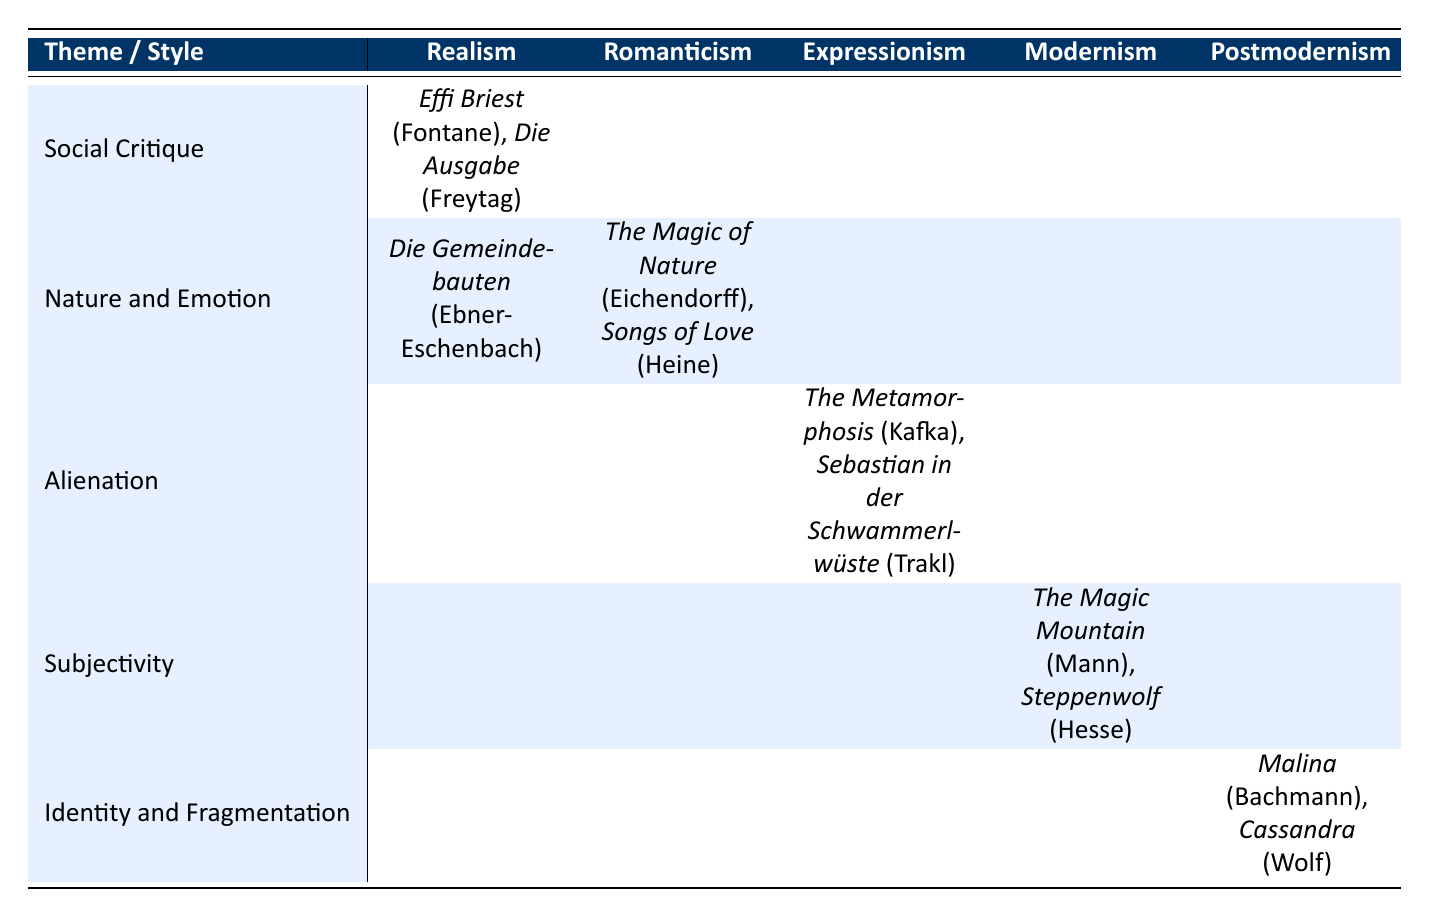What authors are associated with the theme of Social Critique in Realism? The table lists the authors associated with the theme of Social Critique in Realism as Theodor Fontane and Gustav Freytag.
Answer: Theodor Fontane, Gustav Freytag Which works are linked to the theme of Nature and Emotion under Romanticism? The table shows that the works linked to the theme of Nature and Emotion under Romanticism are The Magic of Nature by Joseph von Eichendorff and Songs of Love by Heinrich Heine.
Answer: The Magic of Nature, Songs of Love Is there any work listed under Expressionism that focuses on Alienation? The table indicates that there are works related to Expressionism and the theme of Alienation: The Metamorphosis by Franz Kafka and Sebastian in der Schwammerlwüste by Georg Trakl. This confirms that there are indeed works associated with that theme.
Answer: Yes Count the total number of authors listed in the table. By reviewing the table, the authors are: Theodor Fontane, Gustav Freytag, Marie von Ebner-Eschenbach, Joseph von Eichendorff, Heinrich Heine, Franz Kafka, Georg Trakl, Thomas Mann, Hermann Hesse, Ingeborg Bachmann, and Christa Wolf. This gives a total of 11 unique authors.
Answer: 11 Which writing style has the least number of themes represented in the table? By examining the table, Realism and Postmodernism both have only one theme represented, while others have more. Therefore, they have the least.
Answer: Realism, Postmodernism What is the relationship between Modernism and its theme based on the works listed? The table shows that Modernism is related to the theme of Subjectivity, with works cited being The Magic Mountain by Thomas Mann and Steppenwolf by Hermann Hesse. This means that Modernism deals with the notion of individual perception and personal experience.
Answer: Subjectivity Are there any themes that appear more than once across different writing styles? The table shows that the theme of Nature and Emotion appears under two different writing styles: Realism and Romanticism. Therefore, this theme is represented more than once.
Answer: Yes Identify the authors linked to the theme of Identity and Fragmentation in Postmodernism. According to the table, the authors linked to Identity and Fragmentation under Postmodernism are Ingeborg Bachmann and Christa Wolf.
Answer: Ingeborg Bachmann, Christa Wolf 